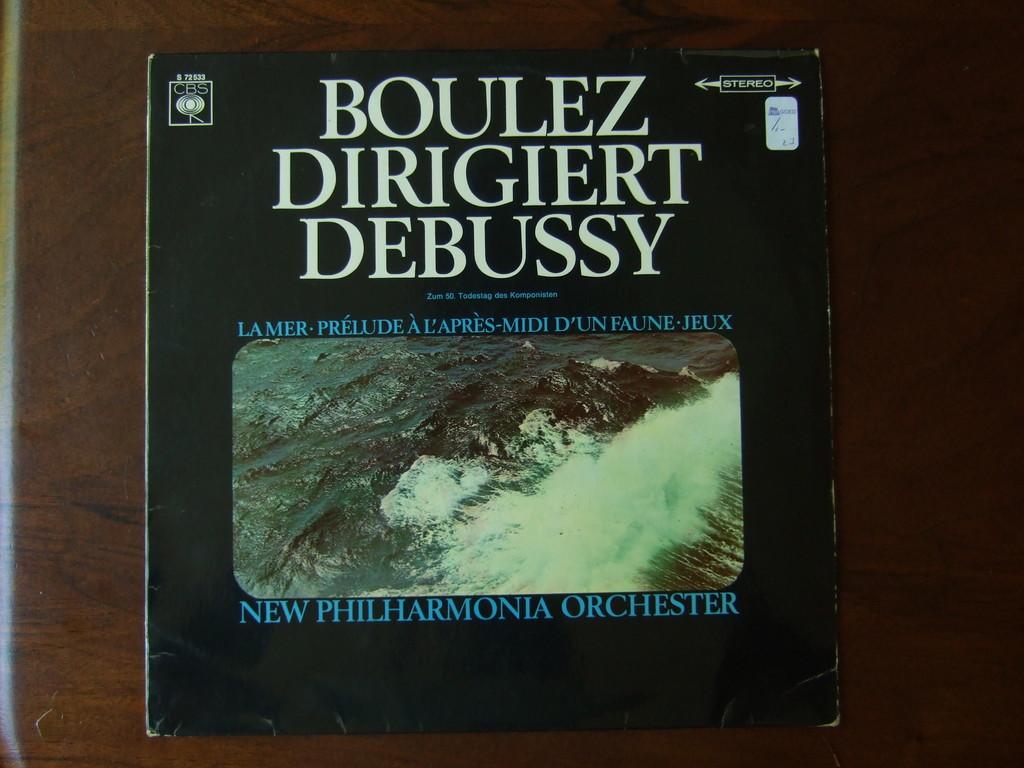What is the name of this album?
Give a very brief answer. Boulez dirigiert debussy. Who performs on the album?
Provide a succinct answer. New philharmonia orchester. 